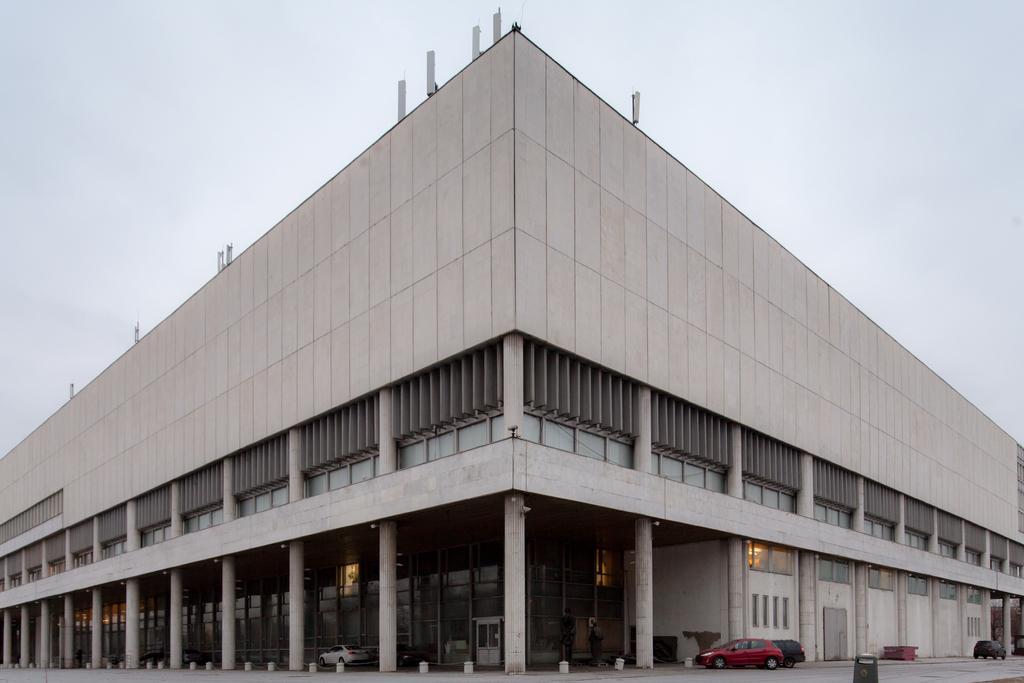What type of structure is depicted in the image? There is a building with pillars in the image. Are there any vehicles visible in the image? Yes, there are vehicles parked near the building. What can be seen in the background of the image? The sky is visible in the background of the image. Where is the brother using the plastic sink in the image? There is no brother or plastic sink present in the image. 